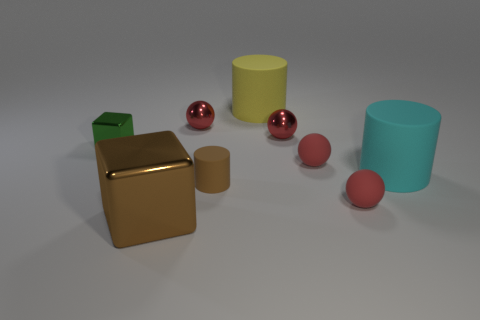Subtract all red spheres. How many were subtracted if there are1red spheres left? 3 Add 1 green shiny blocks. How many objects exist? 10 Subtract all cyan cylinders. How many cylinders are left? 2 Subtract all cyan cylinders. How many cylinders are left? 2 Subtract 2 balls. How many balls are left? 2 Subtract all yellow balls. How many yellow blocks are left? 0 Subtract 0 gray blocks. How many objects are left? 9 Subtract all spheres. How many objects are left? 5 Subtract all blue cylinders. Subtract all yellow cubes. How many cylinders are left? 3 Subtract all matte cylinders. Subtract all large yellow rubber cylinders. How many objects are left? 5 